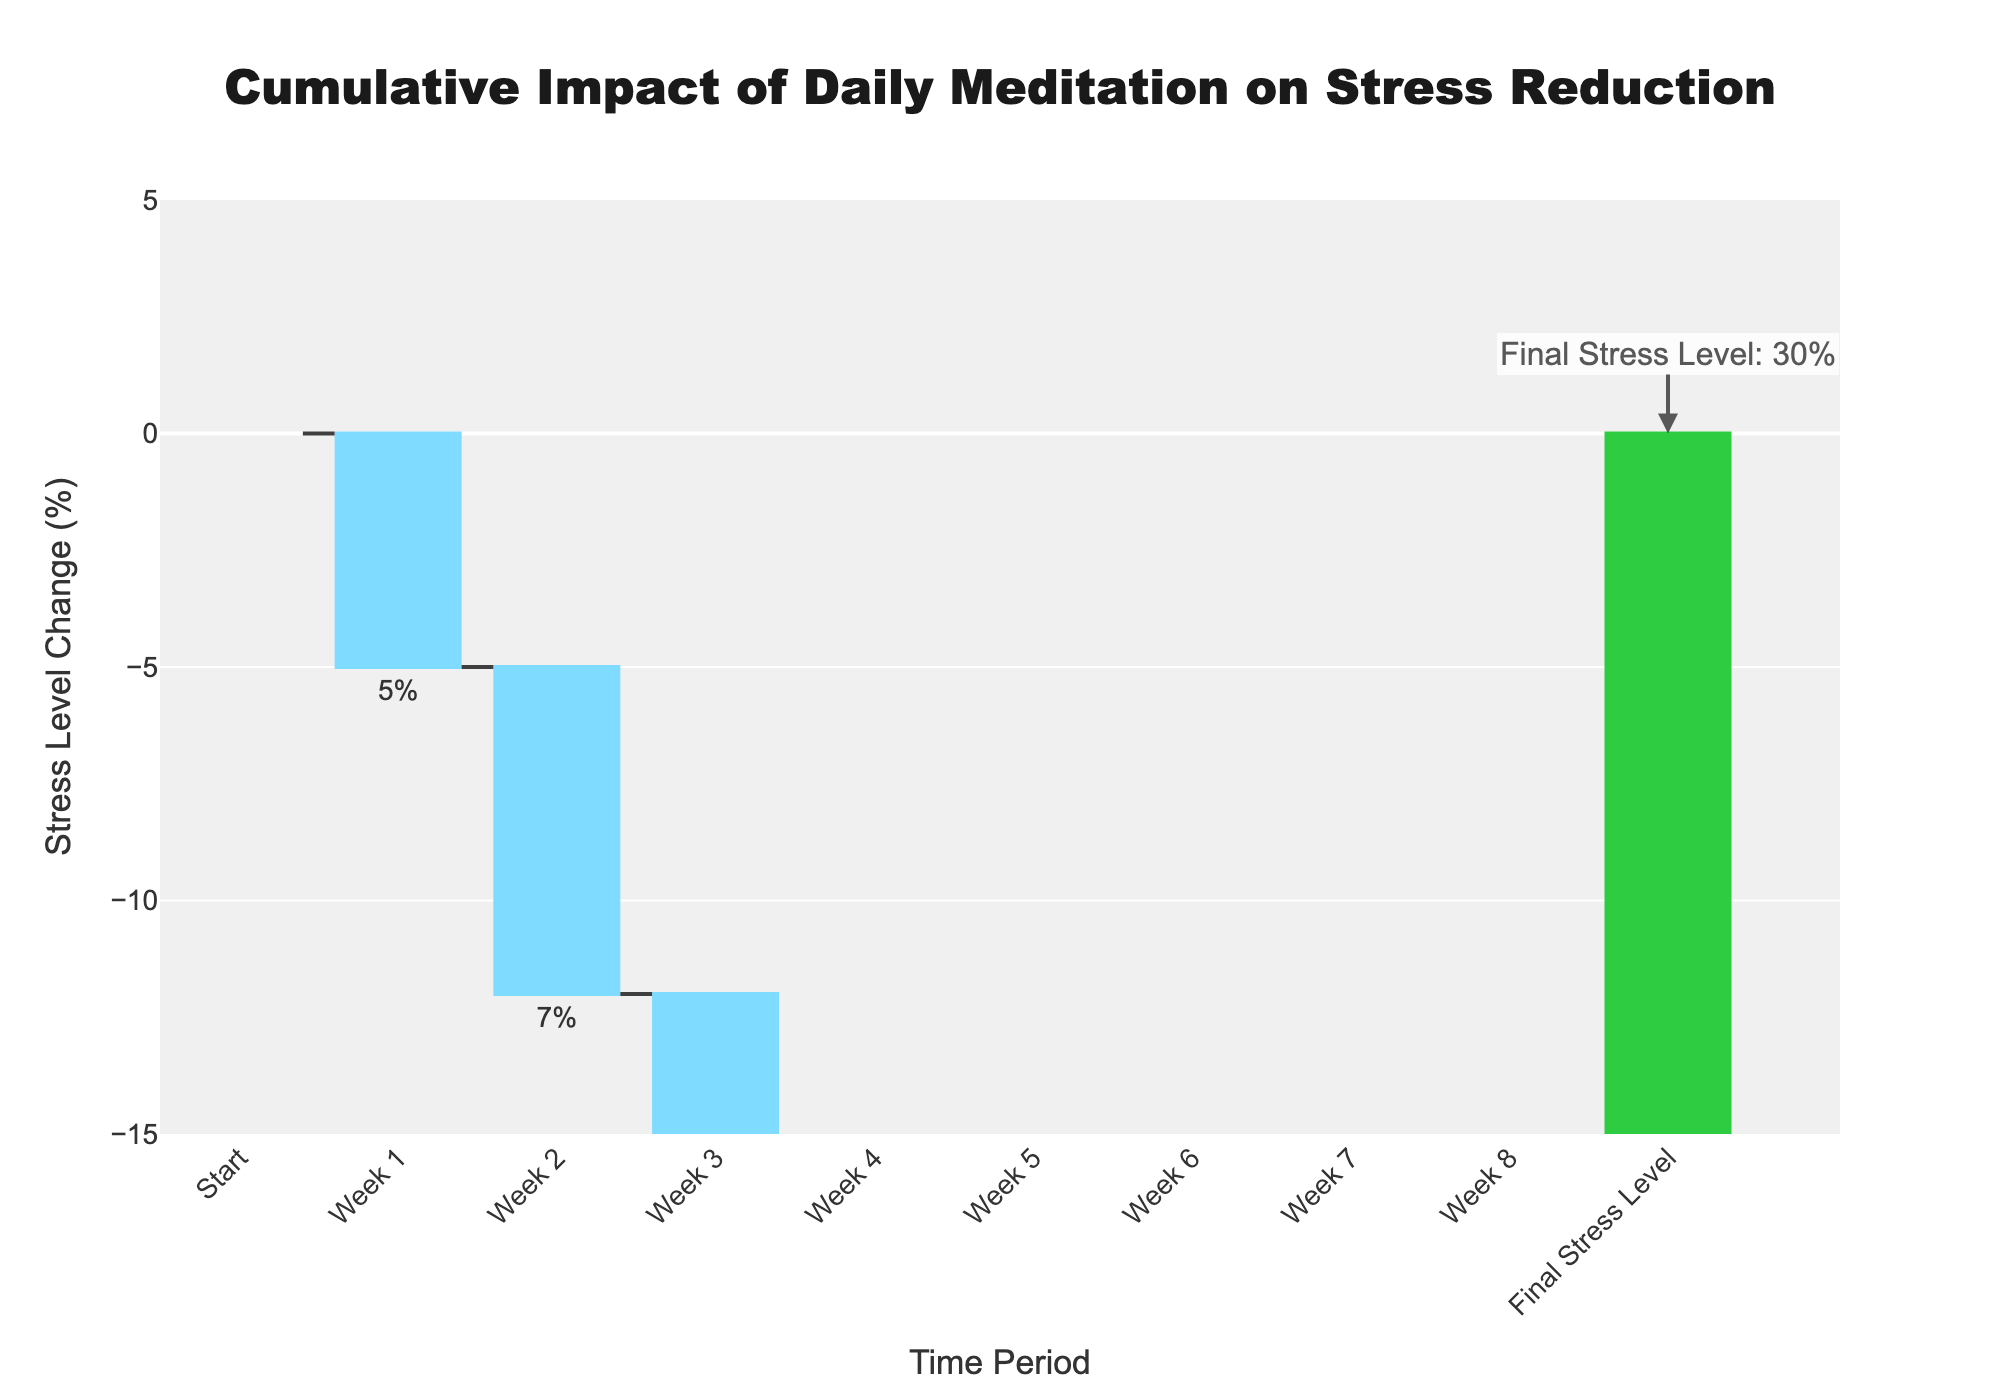What is the title of the plot? The plot's title is located at the top center and clearly states its purpose.
Answer: Cumulative Impact of Daily Meditation on Stress Reduction What is the stress level change during Week 3? The waterfall chart shows relative impacts for each week. For Week 3, the bar descends by 10%.
Answer: -10% By how much does the final stress level reduce after 8 weeks? The final stress level is indicated by the green bar labeled "Final Stress Level" which shows a reduction to 30% from an initial 100%.
Answer: 70% Which week shows the greatest reduction in stress level? By looking at the size of the downward bars, the Week 5 bar is the longest, indicating the greatest reduction. Week 5 has a reduction of 12%.
Answer: Week 5 What is the total cumulative reduction in stress by the end of Week 4? Sum the individual reductions from Week 1 to Week 4: 5% + 7% + 10% + 8% = 30%.
Answer: 30% Compare the stress level reductions in Week 2 and Week 6. Which week had a larger impact? Comparing the values, Week 2 had a reduction of 7%, while Week 6 had 9%. Thus, Week 6 had a larger impact.
Answer: Week 6 What is the stress level after 4 weeks? Starting from 100%, subtract the cumulative reduction by Week 4: 100% - 30% = 70%.
Answer: 70% How does the stress level change from Week 7 to Week 8? Week 7 shows a reduction of 11% and Week 8 has a reduction of 8%, continuing the downward trend.
Answer: Reduced by 8% Give the range of stress level changes shown on the y-axis. The y-axis has a range indicated from -15% to 5%.
Answer: -15% to 5% What is highlighted using green color in the plot? The green color marks the final total impact bar, which is labeled "Final Stress Level," reflecting the overall stress reduction result.
Answer: Final Stress Level 